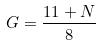<formula> <loc_0><loc_0><loc_500><loc_500>G = \frac { 1 1 + N } { 8 }</formula> 